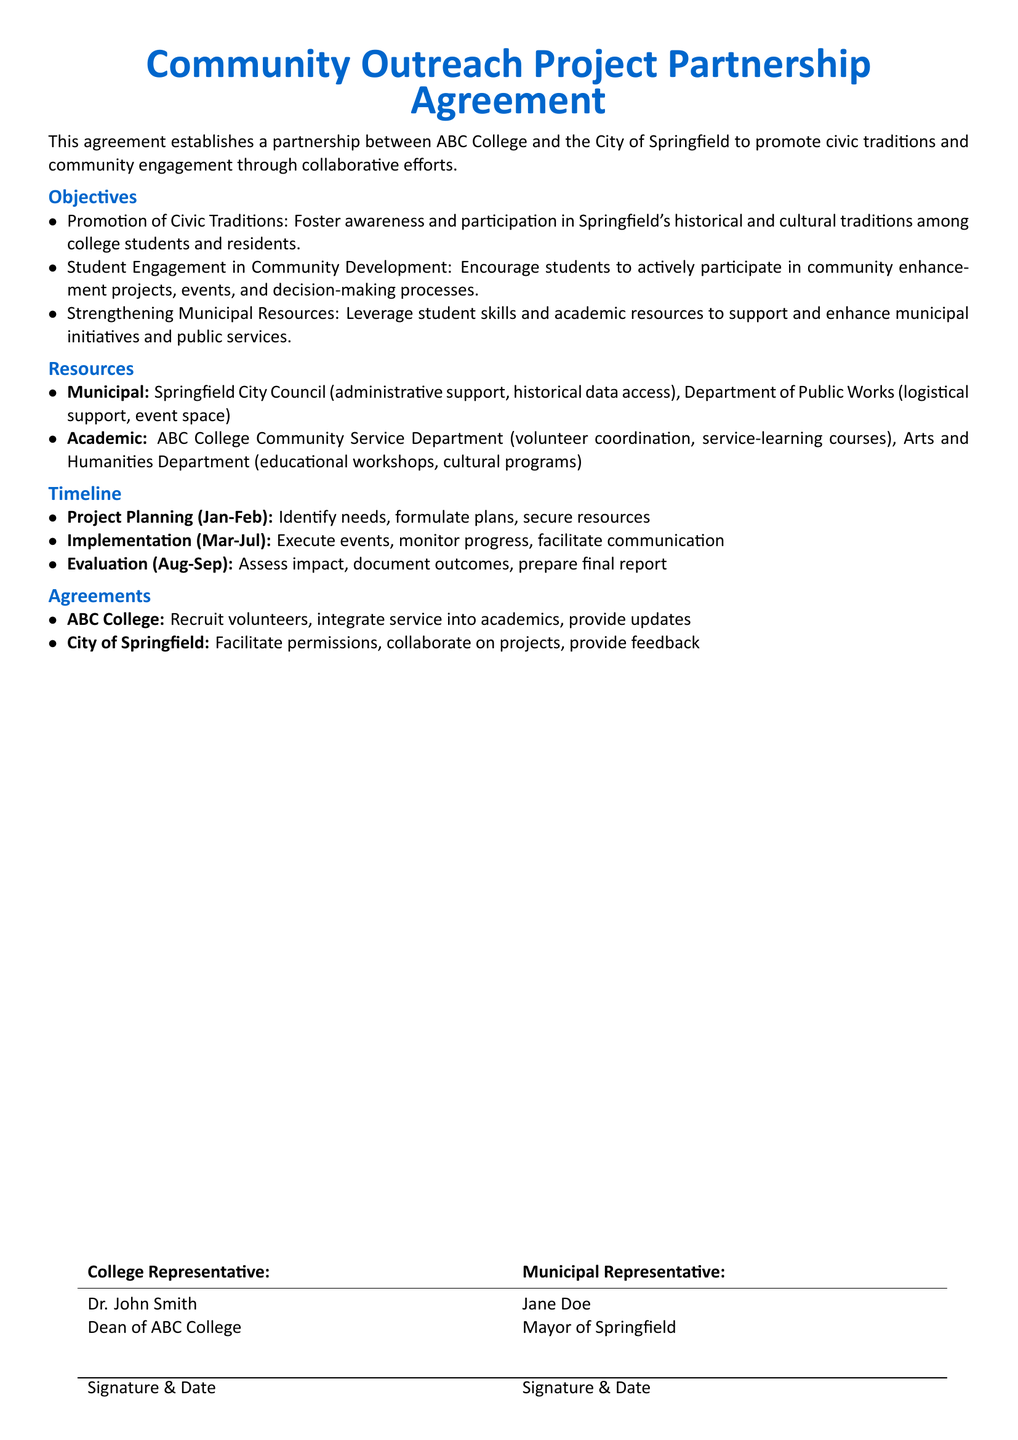what is the title of the document? The title of the document is prominently displayed at the top, indicating the nature of the agreement.
Answer: Community Outreach Project Partnership Agreement who are the parties involved in the agreement? The document identifies the organizations collaborating on the community project.
Answer: ABC College and the City of Springfield what is the first objective of the partnership? The objectives are listed in an itemized format, with the first one regarding civic traditions.
Answer: Promotion of Civic Traditions which department at ABC College is responsible for volunteer coordination? The resources section specifies which academic department will manage volunteers.
Answer: Community Service Department what is the timeframe for project planning? The timeline section outlines the specific months designated for planning activities.
Answer: January-February what does the City of Springfield agree to facilitate? The agreements section mentions specific commitments made by the municipal representative.
Answer: Permissions how long is the implementation phase of the project? Calculation of months from the implementation period will yield the total duration.
Answer: Five months who is the Dean of ABC College? The document lists the Dean’s name in the representative section.
Answer: Dr. John Smith 